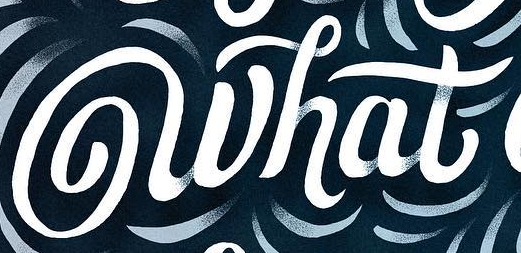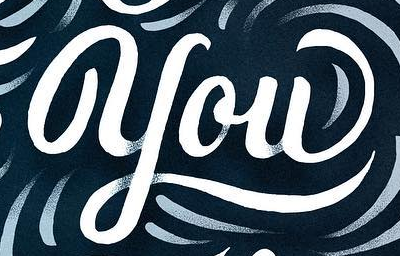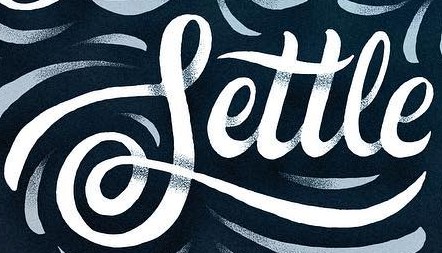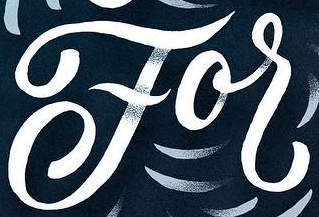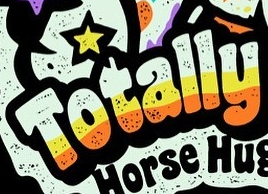Read the text from these images in sequence, separated by a semicolon. what; you; Settle; For; Totally 